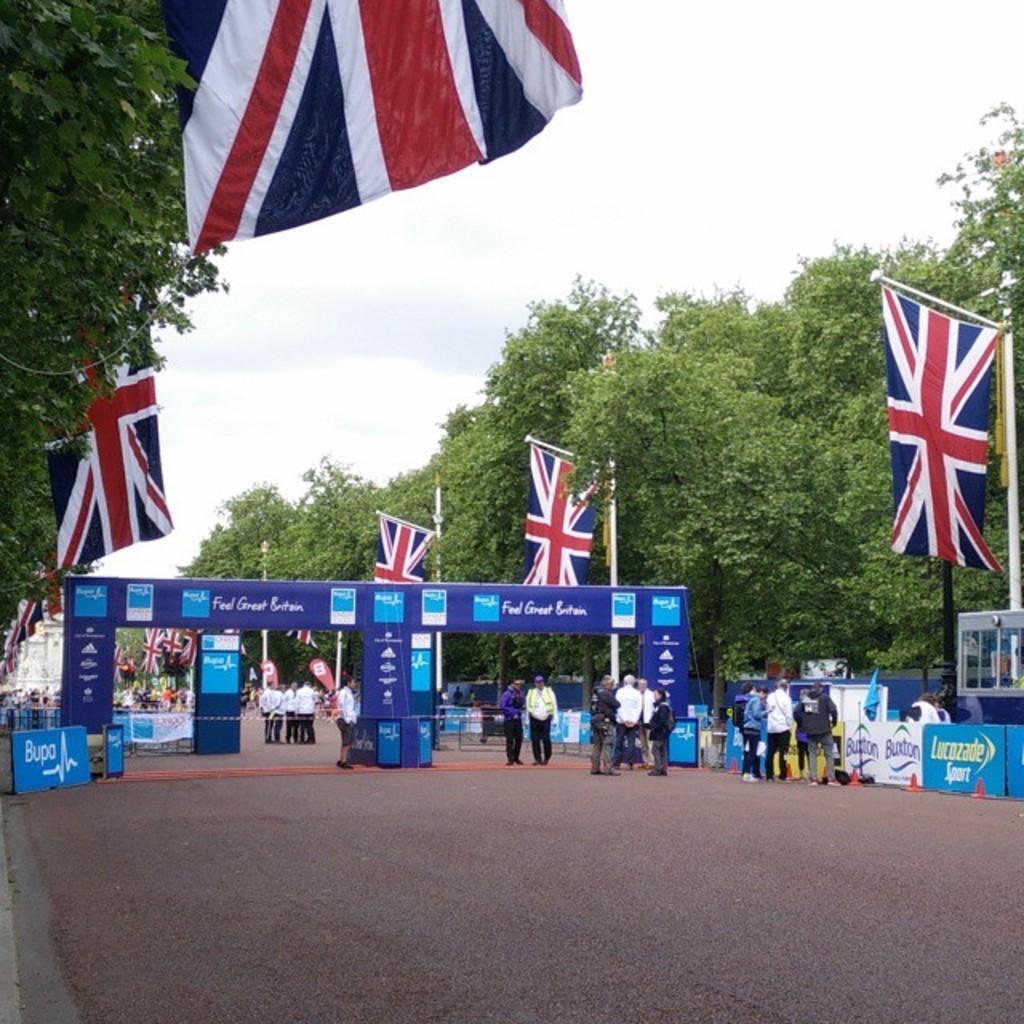How would you summarize this image in a sentence or two? In this image, there are a few people. We can see some poles and flags. We can see some boards with text and images. We can also see some posters. We can see the ground with some objects. There are a few trees. We can also see a white colored object. We can see the sky. 